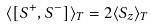Convert formula to latex. <formula><loc_0><loc_0><loc_500><loc_500>\langle [ S ^ { + } , S ^ { - } ] \rangle _ { T } = 2 \langle S _ { z } \rangle _ { T }</formula> 